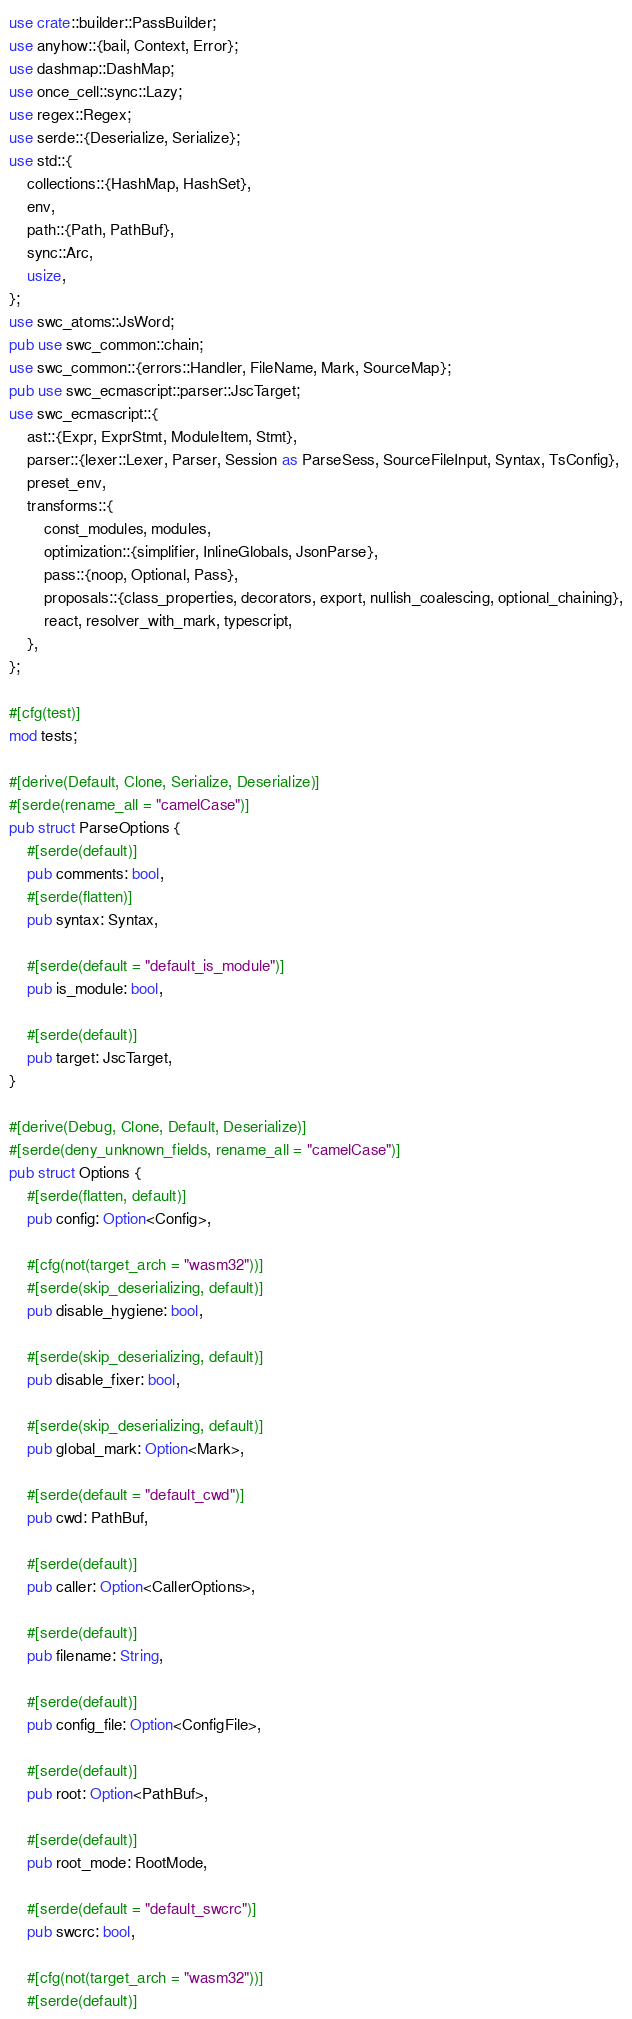<code> <loc_0><loc_0><loc_500><loc_500><_Rust_>use crate::builder::PassBuilder;
use anyhow::{bail, Context, Error};
use dashmap::DashMap;
use once_cell::sync::Lazy;
use regex::Regex;
use serde::{Deserialize, Serialize};
use std::{
    collections::{HashMap, HashSet},
    env,
    path::{Path, PathBuf},
    sync::Arc,
    usize,
};
use swc_atoms::JsWord;
pub use swc_common::chain;
use swc_common::{errors::Handler, FileName, Mark, SourceMap};
pub use swc_ecmascript::parser::JscTarget;
use swc_ecmascript::{
    ast::{Expr, ExprStmt, ModuleItem, Stmt},
    parser::{lexer::Lexer, Parser, Session as ParseSess, SourceFileInput, Syntax, TsConfig},
    preset_env,
    transforms::{
        const_modules, modules,
        optimization::{simplifier, InlineGlobals, JsonParse},
        pass::{noop, Optional, Pass},
        proposals::{class_properties, decorators, export, nullish_coalescing, optional_chaining},
        react, resolver_with_mark, typescript,
    },
};

#[cfg(test)]
mod tests;

#[derive(Default, Clone, Serialize, Deserialize)]
#[serde(rename_all = "camelCase")]
pub struct ParseOptions {
    #[serde(default)]
    pub comments: bool,
    #[serde(flatten)]
    pub syntax: Syntax,

    #[serde(default = "default_is_module")]
    pub is_module: bool,

    #[serde(default)]
    pub target: JscTarget,
}

#[derive(Debug, Clone, Default, Deserialize)]
#[serde(deny_unknown_fields, rename_all = "camelCase")]
pub struct Options {
    #[serde(flatten, default)]
    pub config: Option<Config>,

    #[cfg(not(target_arch = "wasm32"))]
    #[serde(skip_deserializing, default)]
    pub disable_hygiene: bool,

    #[serde(skip_deserializing, default)]
    pub disable_fixer: bool,

    #[serde(skip_deserializing, default)]
    pub global_mark: Option<Mark>,

    #[serde(default = "default_cwd")]
    pub cwd: PathBuf,

    #[serde(default)]
    pub caller: Option<CallerOptions>,

    #[serde(default)]
    pub filename: String,

    #[serde(default)]
    pub config_file: Option<ConfigFile>,

    #[serde(default)]
    pub root: Option<PathBuf>,

    #[serde(default)]
    pub root_mode: RootMode,

    #[serde(default = "default_swcrc")]
    pub swcrc: bool,

    #[cfg(not(target_arch = "wasm32"))]
    #[serde(default)]</code> 